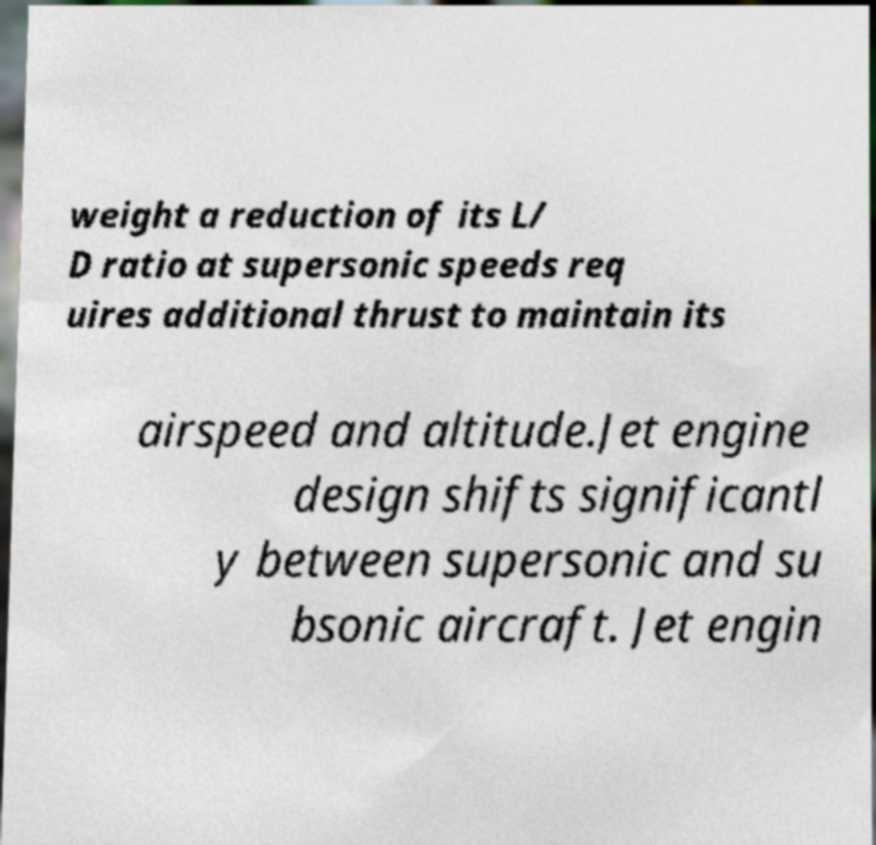I need the written content from this picture converted into text. Can you do that? weight a reduction of its L/ D ratio at supersonic speeds req uires additional thrust to maintain its airspeed and altitude.Jet engine design shifts significantl y between supersonic and su bsonic aircraft. Jet engin 